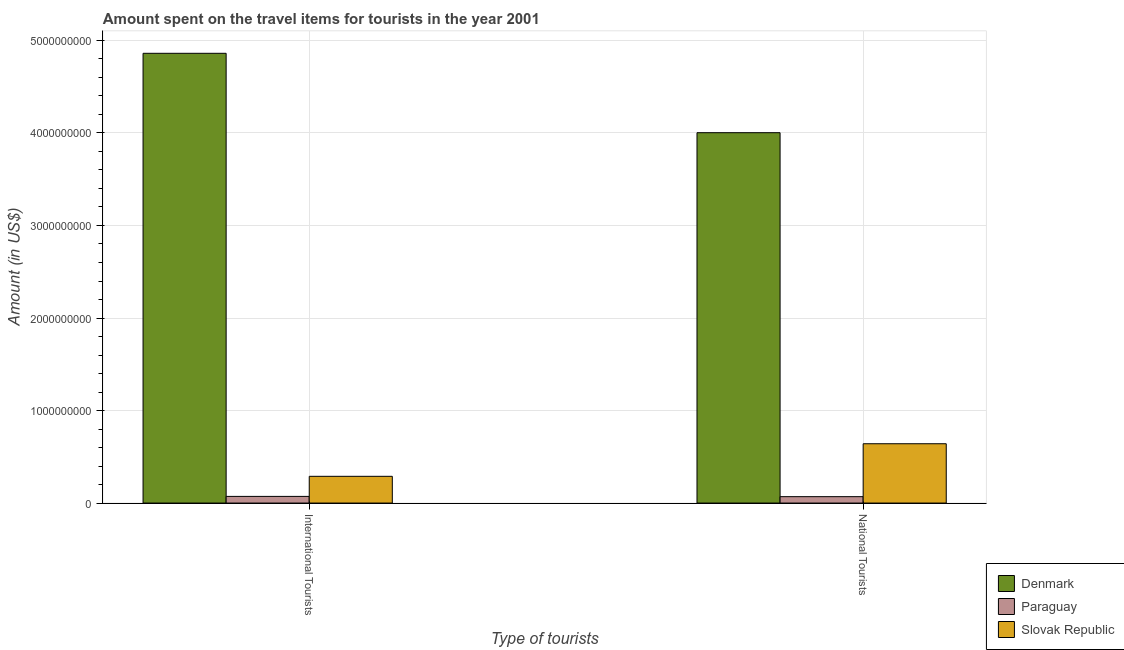Are the number of bars per tick equal to the number of legend labels?
Your answer should be very brief. Yes. Are the number of bars on each tick of the X-axis equal?
Your answer should be compact. Yes. What is the label of the 2nd group of bars from the left?
Provide a succinct answer. National Tourists. What is the amount spent on travel items of national tourists in Slovak Republic?
Your answer should be compact. 6.41e+08. Across all countries, what is the maximum amount spent on travel items of international tourists?
Make the answer very short. 4.86e+09. Across all countries, what is the minimum amount spent on travel items of national tourists?
Give a very brief answer. 6.90e+07. In which country was the amount spent on travel items of national tourists minimum?
Your response must be concise. Paraguay. What is the total amount spent on travel items of international tourists in the graph?
Your response must be concise. 5.22e+09. What is the difference between the amount spent on travel items of national tourists in Slovak Republic and that in Paraguay?
Your response must be concise. 5.72e+08. What is the difference between the amount spent on travel items of international tourists in Paraguay and the amount spent on travel items of national tourists in Slovak Republic?
Give a very brief answer. -5.69e+08. What is the average amount spent on travel items of international tourists per country?
Your response must be concise. 1.74e+09. What is the difference between the amount spent on travel items of national tourists and amount spent on travel items of international tourists in Slovak Republic?
Your answer should be very brief. 3.52e+08. In how many countries, is the amount spent on travel items of national tourists greater than 3800000000 US$?
Offer a very short reply. 1. What is the ratio of the amount spent on travel items of national tourists in Slovak Republic to that in Paraguay?
Your answer should be compact. 9.29. In how many countries, is the amount spent on travel items of national tourists greater than the average amount spent on travel items of national tourists taken over all countries?
Your response must be concise. 1. What does the 2nd bar from the left in International Tourists represents?
Provide a short and direct response. Paraguay. What does the 2nd bar from the right in International Tourists represents?
Offer a very short reply. Paraguay. How many bars are there?
Make the answer very short. 6. How many countries are there in the graph?
Keep it short and to the point. 3. What is the difference between two consecutive major ticks on the Y-axis?
Offer a very short reply. 1.00e+09. Are the values on the major ticks of Y-axis written in scientific E-notation?
Offer a very short reply. No. Does the graph contain any zero values?
Ensure brevity in your answer.  No. How many legend labels are there?
Give a very brief answer. 3. What is the title of the graph?
Ensure brevity in your answer.  Amount spent on the travel items for tourists in the year 2001. Does "Norway" appear as one of the legend labels in the graph?
Provide a succinct answer. No. What is the label or title of the X-axis?
Offer a terse response. Type of tourists. What is the label or title of the Y-axis?
Your response must be concise. Amount (in US$). What is the Amount (in US$) in Denmark in International Tourists?
Provide a succinct answer. 4.86e+09. What is the Amount (in US$) of Paraguay in International Tourists?
Provide a succinct answer. 7.20e+07. What is the Amount (in US$) of Slovak Republic in International Tourists?
Make the answer very short. 2.89e+08. What is the Amount (in US$) of Denmark in National Tourists?
Make the answer very short. 4.00e+09. What is the Amount (in US$) of Paraguay in National Tourists?
Your answer should be very brief. 6.90e+07. What is the Amount (in US$) of Slovak Republic in National Tourists?
Ensure brevity in your answer.  6.41e+08. Across all Type of tourists, what is the maximum Amount (in US$) of Denmark?
Your answer should be very brief. 4.86e+09. Across all Type of tourists, what is the maximum Amount (in US$) of Paraguay?
Keep it short and to the point. 7.20e+07. Across all Type of tourists, what is the maximum Amount (in US$) in Slovak Republic?
Keep it short and to the point. 6.41e+08. Across all Type of tourists, what is the minimum Amount (in US$) of Denmark?
Your answer should be very brief. 4.00e+09. Across all Type of tourists, what is the minimum Amount (in US$) of Paraguay?
Your response must be concise. 6.90e+07. Across all Type of tourists, what is the minimum Amount (in US$) in Slovak Republic?
Provide a succinct answer. 2.89e+08. What is the total Amount (in US$) in Denmark in the graph?
Your answer should be compact. 8.86e+09. What is the total Amount (in US$) in Paraguay in the graph?
Your answer should be very brief. 1.41e+08. What is the total Amount (in US$) in Slovak Republic in the graph?
Keep it short and to the point. 9.30e+08. What is the difference between the Amount (in US$) in Denmark in International Tourists and that in National Tourists?
Keep it short and to the point. 8.58e+08. What is the difference between the Amount (in US$) in Slovak Republic in International Tourists and that in National Tourists?
Your response must be concise. -3.52e+08. What is the difference between the Amount (in US$) in Denmark in International Tourists and the Amount (in US$) in Paraguay in National Tourists?
Offer a very short reply. 4.79e+09. What is the difference between the Amount (in US$) of Denmark in International Tourists and the Amount (in US$) of Slovak Republic in National Tourists?
Your response must be concise. 4.22e+09. What is the difference between the Amount (in US$) in Paraguay in International Tourists and the Amount (in US$) in Slovak Republic in National Tourists?
Keep it short and to the point. -5.69e+08. What is the average Amount (in US$) in Denmark per Type of tourists?
Your answer should be compact. 4.43e+09. What is the average Amount (in US$) of Paraguay per Type of tourists?
Ensure brevity in your answer.  7.05e+07. What is the average Amount (in US$) in Slovak Republic per Type of tourists?
Keep it short and to the point. 4.65e+08. What is the difference between the Amount (in US$) in Denmark and Amount (in US$) in Paraguay in International Tourists?
Keep it short and to the point. 4.79e+09. What is the difference between the Amount (in US$) of Denmark and Amount (in US$) of Slovak Republic in International Tourists?
Make the answer very short. 4.57e+09. What is the difference between the Amount (in US$) of Paraguay and Amount (in US$) of Slovak Republic in International Tourists?
Your answer should be compact. -2.17e+08. What is the difference between the Amount (in US$) in Denmark and Amount (in US$) in Paraguay in National Tourists?
Keep it short and to the point. 3.93e+09. What is the difference between the Amount (in US$) in Denmark and Amount (in US$) in Slovak Republic in National Tourists?
Offer a very short reply. 3.36e+09. What is the difference between the Amount (in US$) of Paraguay and Amount (in US$) of Slovak Republic in National Tourists?
Your response must be concise. -5.72e+08. What is the ratio of the Amount (in US$) of Denmark in International Tourists to that in National Tourists?
Make the answer very short. 1.21. What is the ratio of the Amount (in US$) in Paraguay in International Tourists to that in National Tourists?
Your answer should be very brief. 1.04. What is the ratio of the Amount (in US$) of Slovak Republic in International Tourists to that in National Tourists?
Provide a succinct answer. 0.45. What is the difference between the highest and the second highest Amount (in US$) of Denmark?
Make the answer very short. 8.58e+08. What is the difference between the highest and the second highest Amount (in US$) in Paraguay?
Your response must be concise. 3.00e+06. What is the difference between the highest and the second highest Amount (in US$) of Slovak Republic?
Make the answer very short. 3.52e+08. What is the difference between the highest and the lowest Amount (in US$) of Denmark?
Provide a succinct answer. 8.58e+08. What is the difference between the highest and the lowest Amount (in US$) in Paraguay?
Ensure brevity in your answer.  3.00e+06. What is the difference between the highest and the lowest Amount (in US$) of Slovak Republic?
Provide a succinct answer. 3.52e+08. 